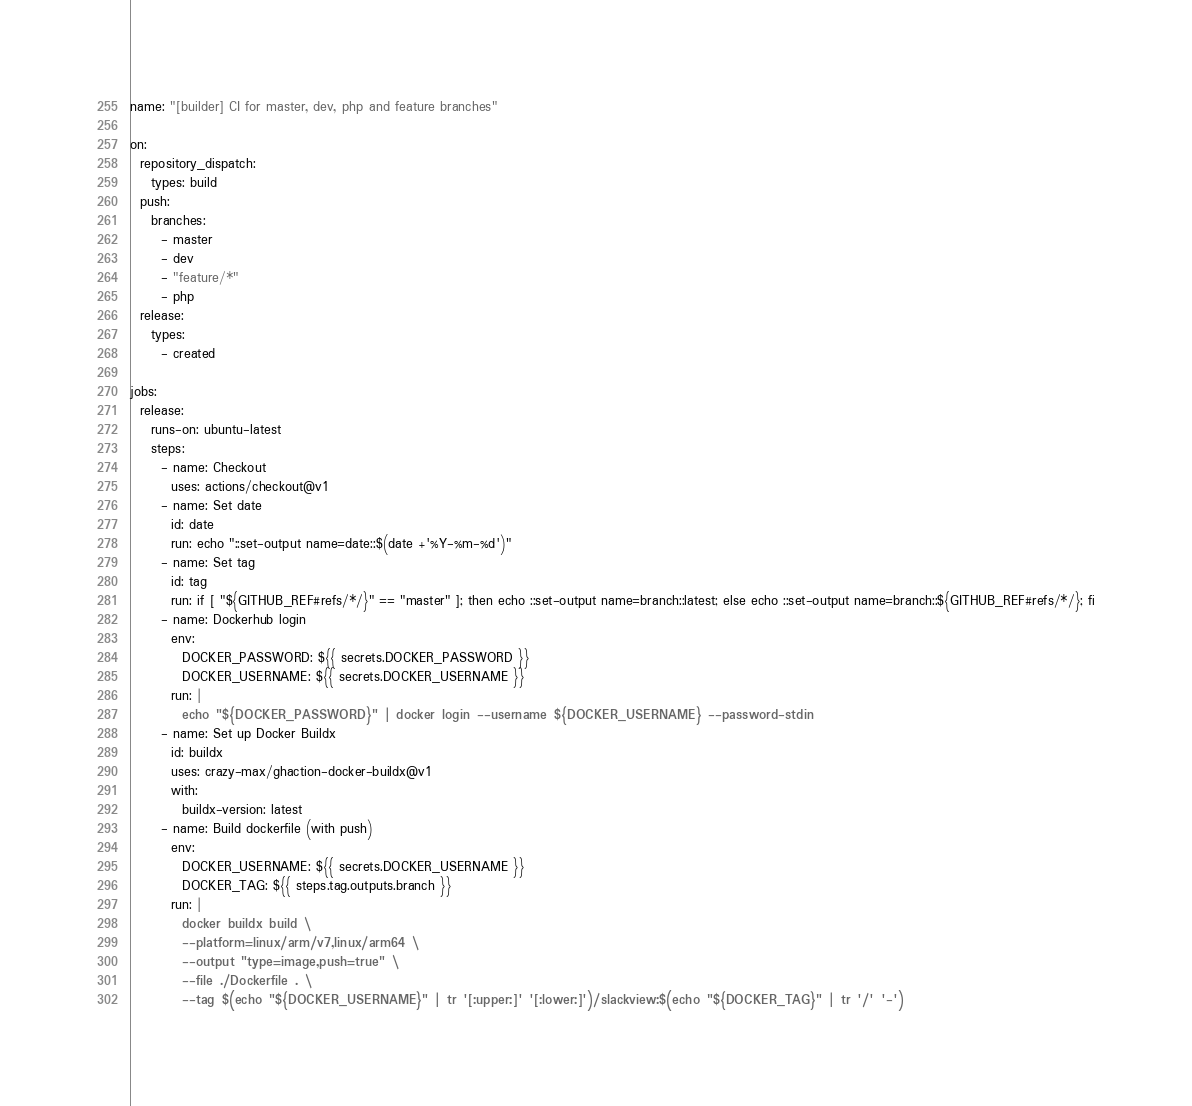<code> <loc_0><loc_0><loc_500><loc_500><_YAML_>name: "[builder] CI for master, dev, php and feature branches"

on:
  repository_dispatch:
    types: build
  push:
    branches:
      - master
      - dev
      - "feature/*"
      - php
  release:
    types:
      - created

jobs:
  release:
    runs-on: ubuntu-latest
    steps:
      - name: Checkout
        uses: actions/checkout@v1
      - name: Set date
        id: date
        run: echo "::set-output name=date::$(date +'%Y-%m-%d')"
      - name: Set tag
        id: tag
        run: if [ "${GITHUB_REF#refs/*/}" == "master" ]; then echo ::set-output name=branch::latest; else echo ::set-output name=branch::${GITHUB_REF#refs/*/}; fi
      - name: Dockerhub login
        env:
          DOCKER_PASSWORD: ${{ secrets.DOCKER_PASSWORD }}
          DOCKER_USERNAME: ${{ secrets.DOCKER_USERNAME }}
        run: |
          echo "${DOCKER_PASSWORD}" | docker login --username ${DOCKER_USERNAME} --password-stdin
      - name: Set up Docker Buildx
        id: buildx
        uses: crazy-max/ghaction-docker-buildx@v1
        with:
          buildx-version: latest
      - name: Build dockerfile (with push)
        env:
          DOCKER_USERNAME: ${{ secrets.DOCKER_USERNAME }}
          DOCKER_TAG: ${{ steps.tag.outputs.branch }}
        run: |
          docker buildx build \
          --platform=linux/arm/v7,linux/arm64 \
          --output "type=image,push=true" \
          --file ./Dockerfile . \
          --tag $(echo "${DOCKER_USERNAME}" | tr '[:upper:]' '[:lower:]')/slackview:$(echo "${DOCKER_TAG}" | tr '/' '-')
</code> 